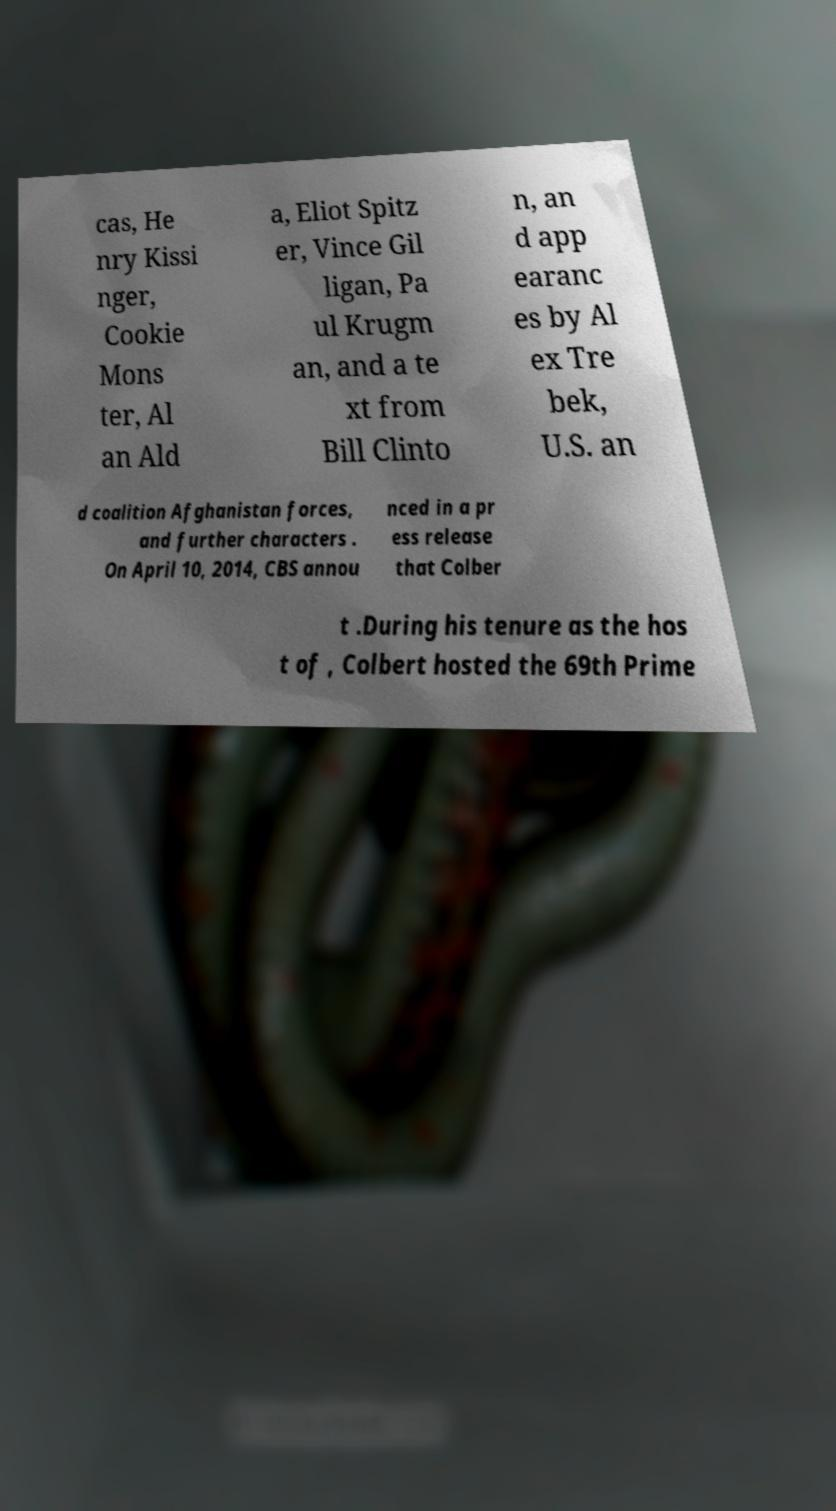Can you accurately transcribe the text from the provided image for me? cas, He nry Kissi nger, Cookie Mons ter, Al an Ald a, Eliot Spitz er, Vince Gil ligan, Pa ul Krugm an, and a te xt from Bill Clinto n, an d app earanc es by Al ex Tre bek, U.S. an d coalition Afghanistan forces, and further characters . On April 10, 2014, CBS annou nced in a pr ess release that Colber t .During his tenure as the hos t of , Colbert hosted the 69th Prime 